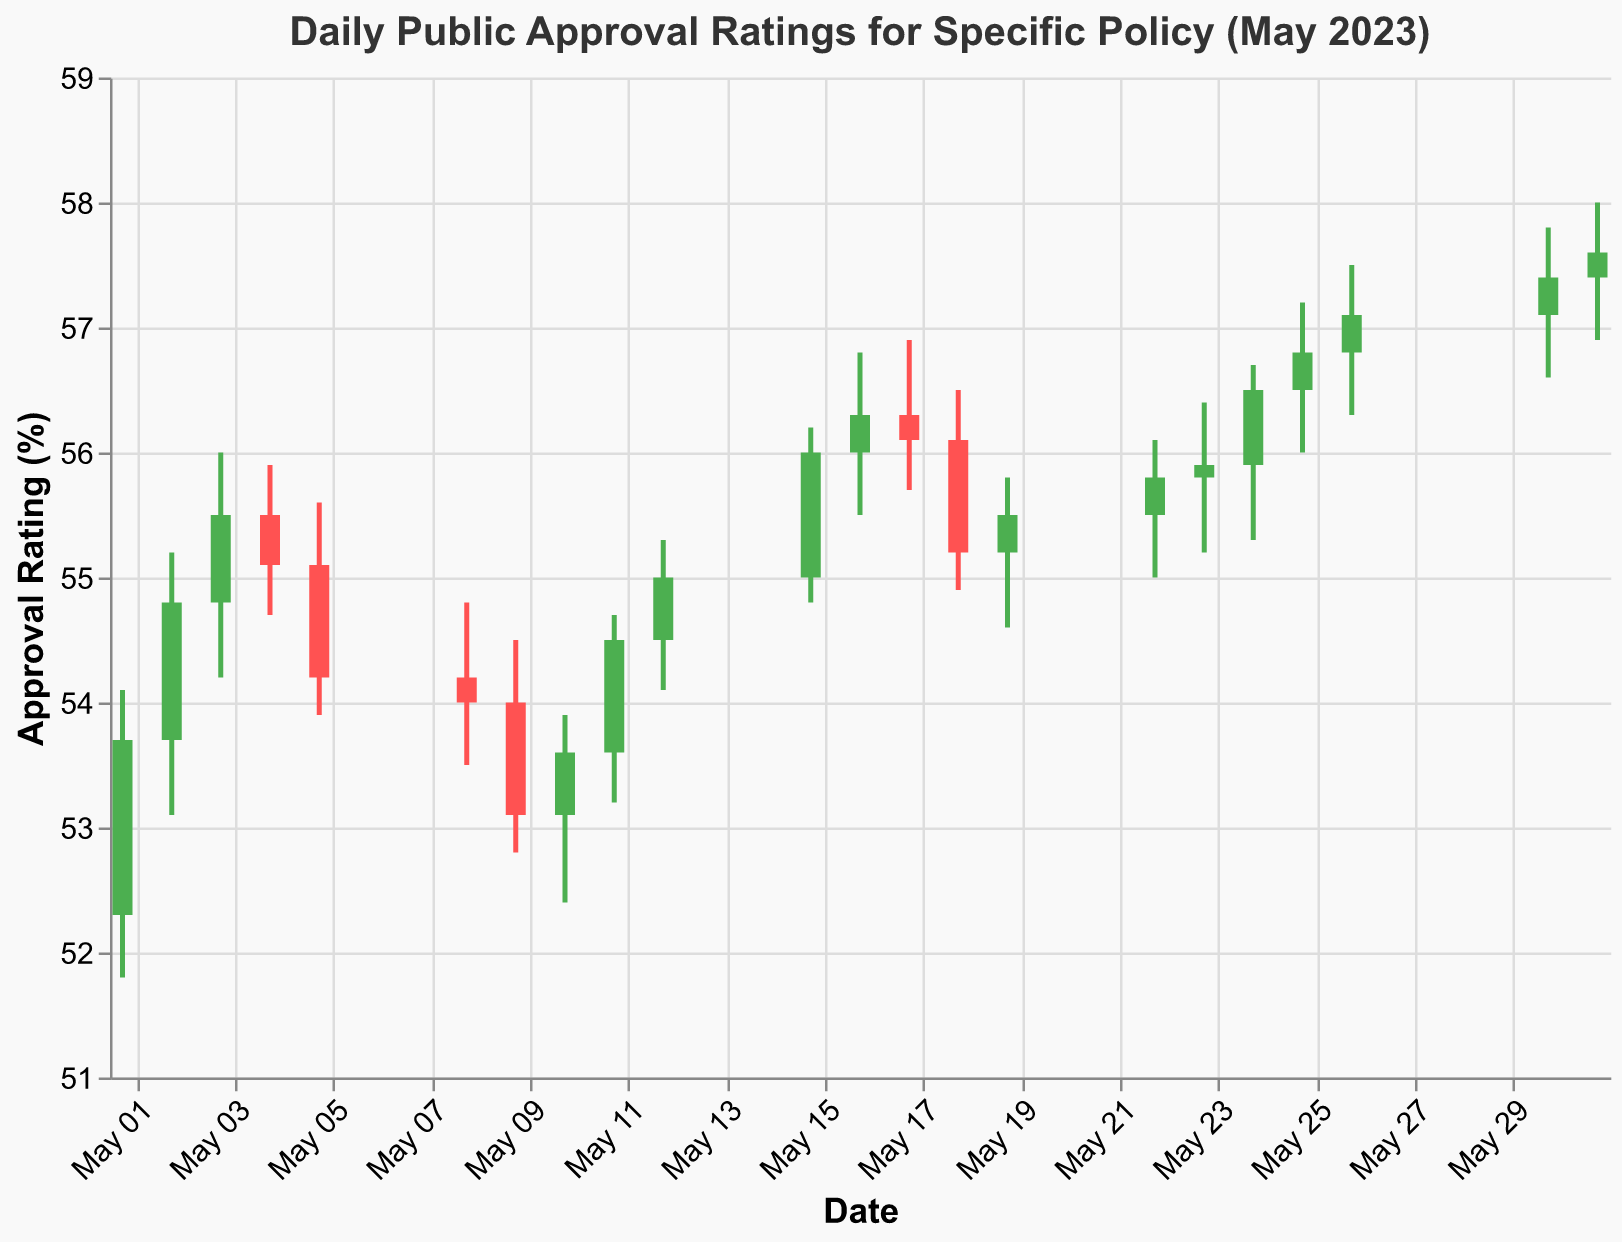What is the title of the chart? The title of the chart is usually located at the top of the figure. Here, it states, "Daily Public Approval Ratings for Specific Policy (May 2023)."
Answer: Daily Public Approval Ratings for Specific Policy (May 2023) What is the highest approval rating recorded in May 2023? The highest approval rating can be found by looking at the highest point in the 'High' column in the data. On 2023-05-31, the highest rating is 58.0%.
Answer: 58.0% On which date did the approval rating close at its lowest value, and what was that value? To identify the lowest closing value, find the minimum value in the 'Close' column. The lowest closing value is on 2023-05-09, which is 53.1%.
Answer: 2023-05-09, 53.1% Which date had the greatest intraday fluctuation in approval rating, and what was the range? The greatest intraday fluctuation can be calculated by taking the difference between the High and Low values for each date. The maximum range is on 2023-05-31 (High 58.0% - Low 56.9%) which results in 1.1%.
Answer: 2023-05-31, 1.1% How many days did the closing approval rating increase compared to the opening rating? Count the number of days where the closing value is greater than the opening value. On May 1, 2, 3, 11, 12, 15, 16, 19, 22, 23, 24, 25, 26, 30, and 31, the closing rating increased compared to the opening, totaling 15 days.
Answer: 15 days On which date did the approval rating have the smallest difference between the opening and closing values, and what was the difference? Find the difference between the opening and closing values for each date, then identify the smallest difference. On 2023-05-08 and 2023-05-23, the difference is 0.2%.
Answer: 2023-05-08 and 2023-05-23, 0.2% What was the average closing approval rating for the month of May 2023? To calculate the average closing rating, sum all the closing values and divide by the number of data points. Sum of closing values: 53.7+54.8+55.5+55.1+54.2+54.0+53.1+53.6+54.5+55.0+56.0+56.3+56.1+55.2+55.5+55.8+55.9+56.5+56.8+57.1+57.4+57.6 = 1227.7. Divide by 22 (number of days): 1227.7/22 ≈ 55.8
Answer: 55.8% Did the public approval rating end higher or lower at the end of May compared to the beginning? Compare the closing value on the first and last date. May 1st's closing value is 53.7% and May 31st's is 57.6%. As 57.6% is greater than 53.7%, the rating ended higher.
Answer: Higher How many days did the approval rating stay above 55% at closing? Count the number of days where the closing value is greater than or equal to 55%. The approval rating stayed above 55% on May 3, 4, 11, 12, 15, 16, 17, 19, 22, 23, 24, 25, 26, 30, and 31, totaling 15 days.
Answer: 15 days What is the median closing approval rating for May 2023? To find the median, first list the closing values in ascending order. The median is the middle value in this ordered list. Ordered closing values: 53.1, 53.6, 54.0, 54.2, 54.5, 54.8, 55.0, 55.1, 55.2, 55.5, 55.5, 55.8, 55.9, 56.0, 56.1, 56.3, 56.5, 56.8, 57.1, 57.4, 57.6. The middle value (11th in this list) is the average of 55.5.
Answer: 55.5% 